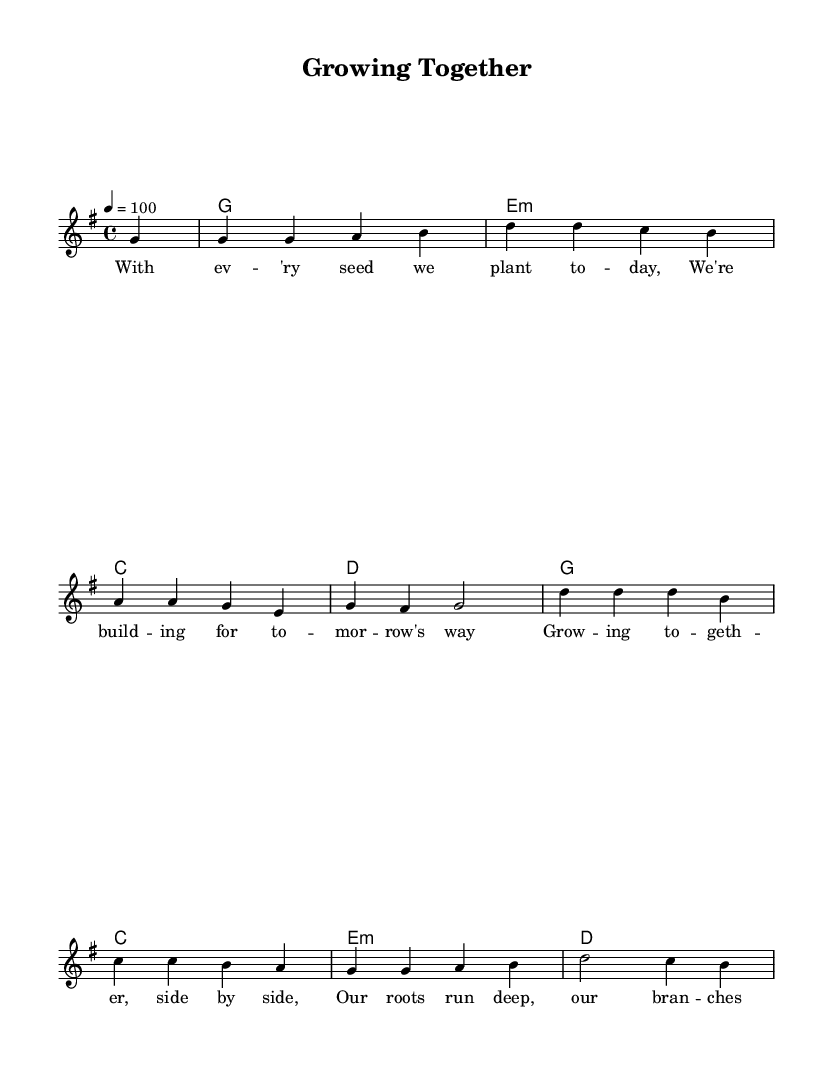What is the key signature of this music? The key signature indicates that this piece is in G major, which has one sharp (F#). This can be identified by looking at the key signature at the beginning of the sheet music.
Answer: G major What is the time signature of this piece? The time signature at the start of the music is 4/4, meaning there are four beats in each measure and a quarter note receives one beat. This is determined by the notation that precedes the melody.
Answer: 4/4 What is the tempo marking for this piece? The tempo marking indicates that the piece should be played at a speed of 100 beats per minute. This is noted at the beginning, right above the melody part.
Answer: 100 How many measures are there in the melody? Counting each measure in the provided melody section shows there are eight measures in total, which can be identified by the bar lines that separate each measure.
Answer: 8 What is the first note of the melody? The first note of the melody is a G, which can be identified from the first note shown in the melody section at the start of the score.
Answer: G What emotions or themes does this song convey based on the lyrics? The lyrics speak about community cooperation, growth, and deep connections, suggesting a positive message about working together and supporting each other. This can be inferred by analyzing the words presented in the lyrics.
Answer: Community cooperation Which chord follows the second measure in the harmonies? The chord following the second measure is E minor, which can be determined by identifying the chord notation alongside the measures in the harmonies section of the sheet music.
Answer: E minor 